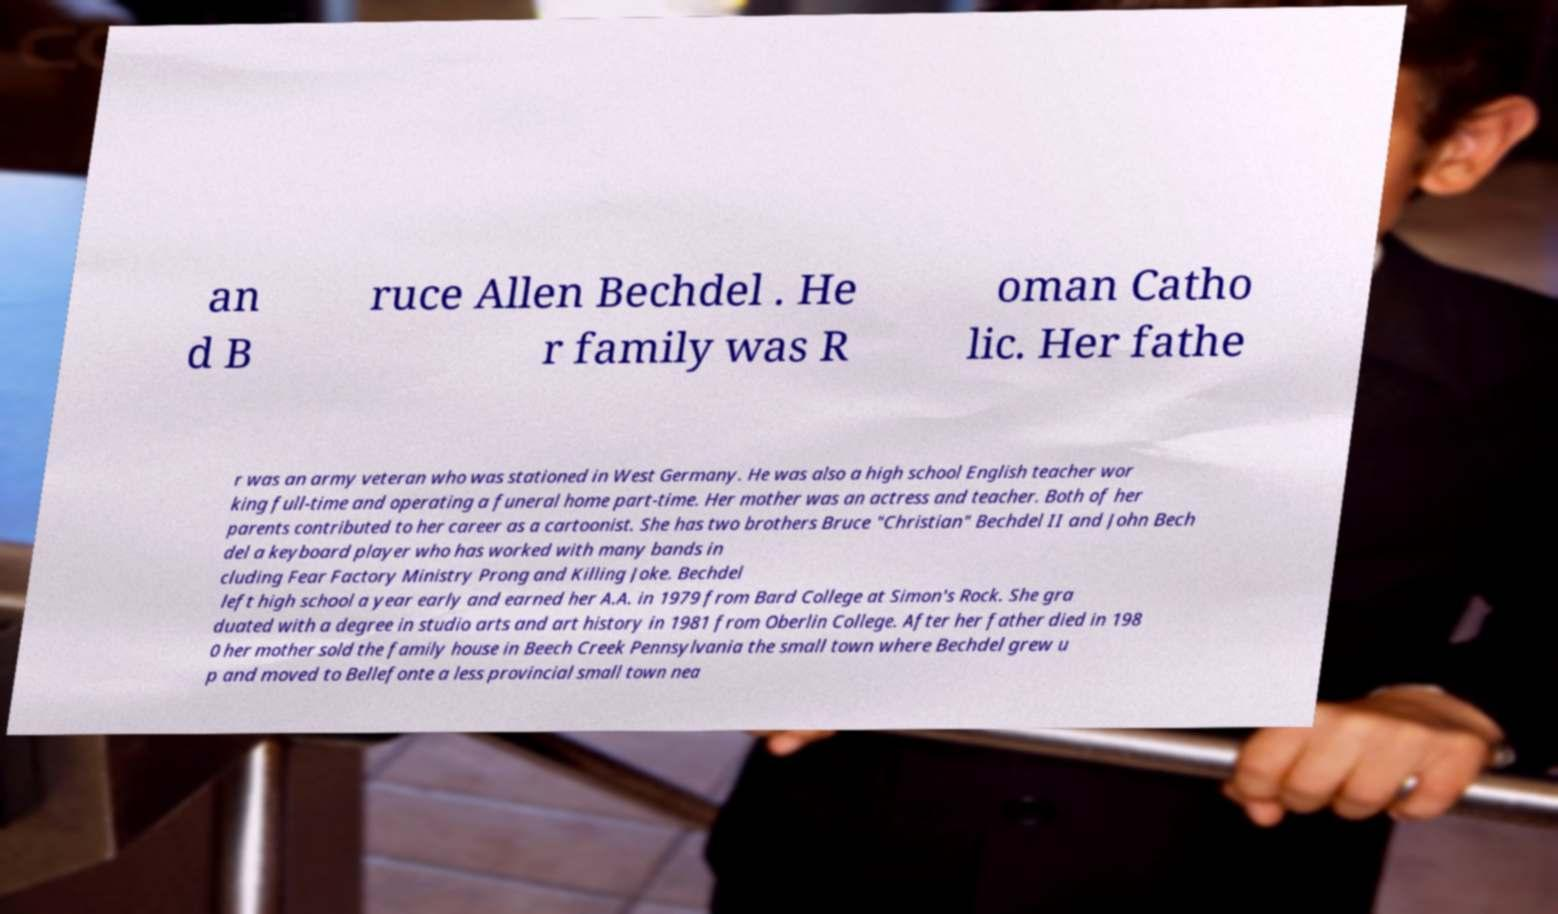There's text embedded in this image that I need extracted. Can you transcribe it verbatim? an d B ruce Allen Bechdel . He r family was R oman Catho lic. Her fathe r was an army veteran who was stationed in West Germany. He was also a high school English teacher wor king full-time and operating a funeral home part-time. Her mother was an actress and teacher. Both of her parents contributed to her career as a cartoonist. She has two brothers Bruce "Christian" Bechdel II and John Bech del a keyboard player who has worked with many bands in cluding Fear Factory Ministry Prong and Killing Joke. Bechdel left high school a year early and earned her A.A. in 1979 from Bard College at Simon's Rock. She gra duated with a degree in studio arts and art history in 1981 from Oberlin College. After her father died in 198 0 her mother sold the family house in Beech Creek Pennsylvania the small town where Bechdel grew u p and moved to Bellefonte a less provincial small town nea 